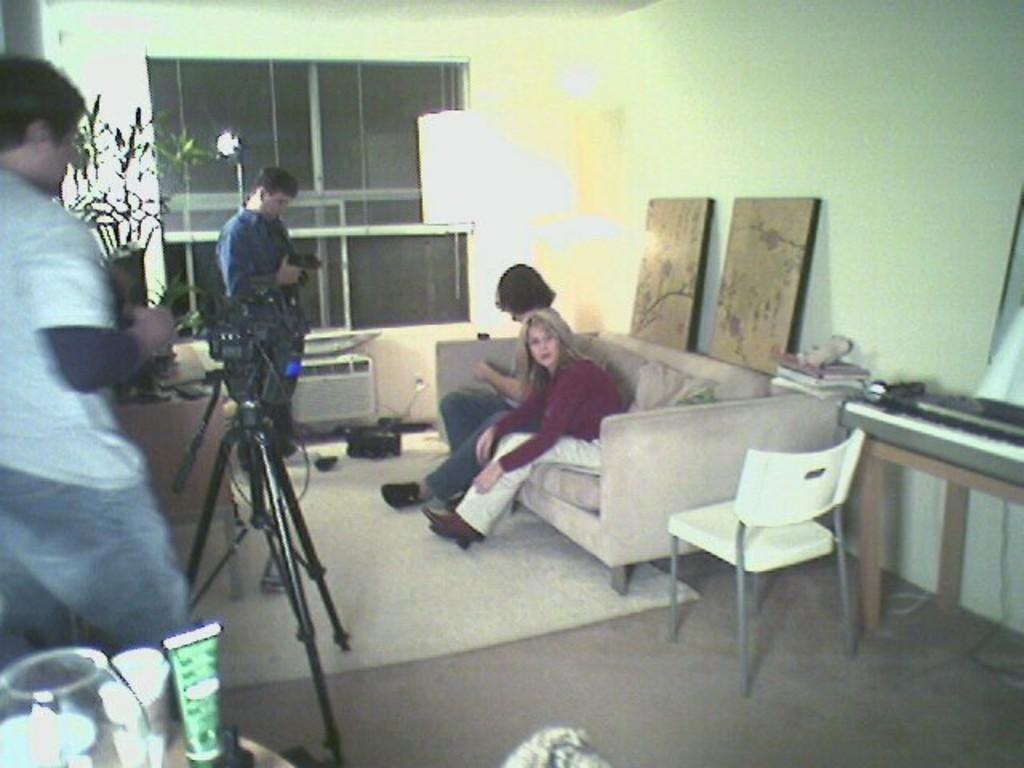Can you describe this image briefly? Here we can see two persons are sitting on the sofa, and at side here is the chair on the floor, and in front there are two persons standing, and here is the stand, and at back here is the wall, and here is the table and some objects on it, and here is the light. 